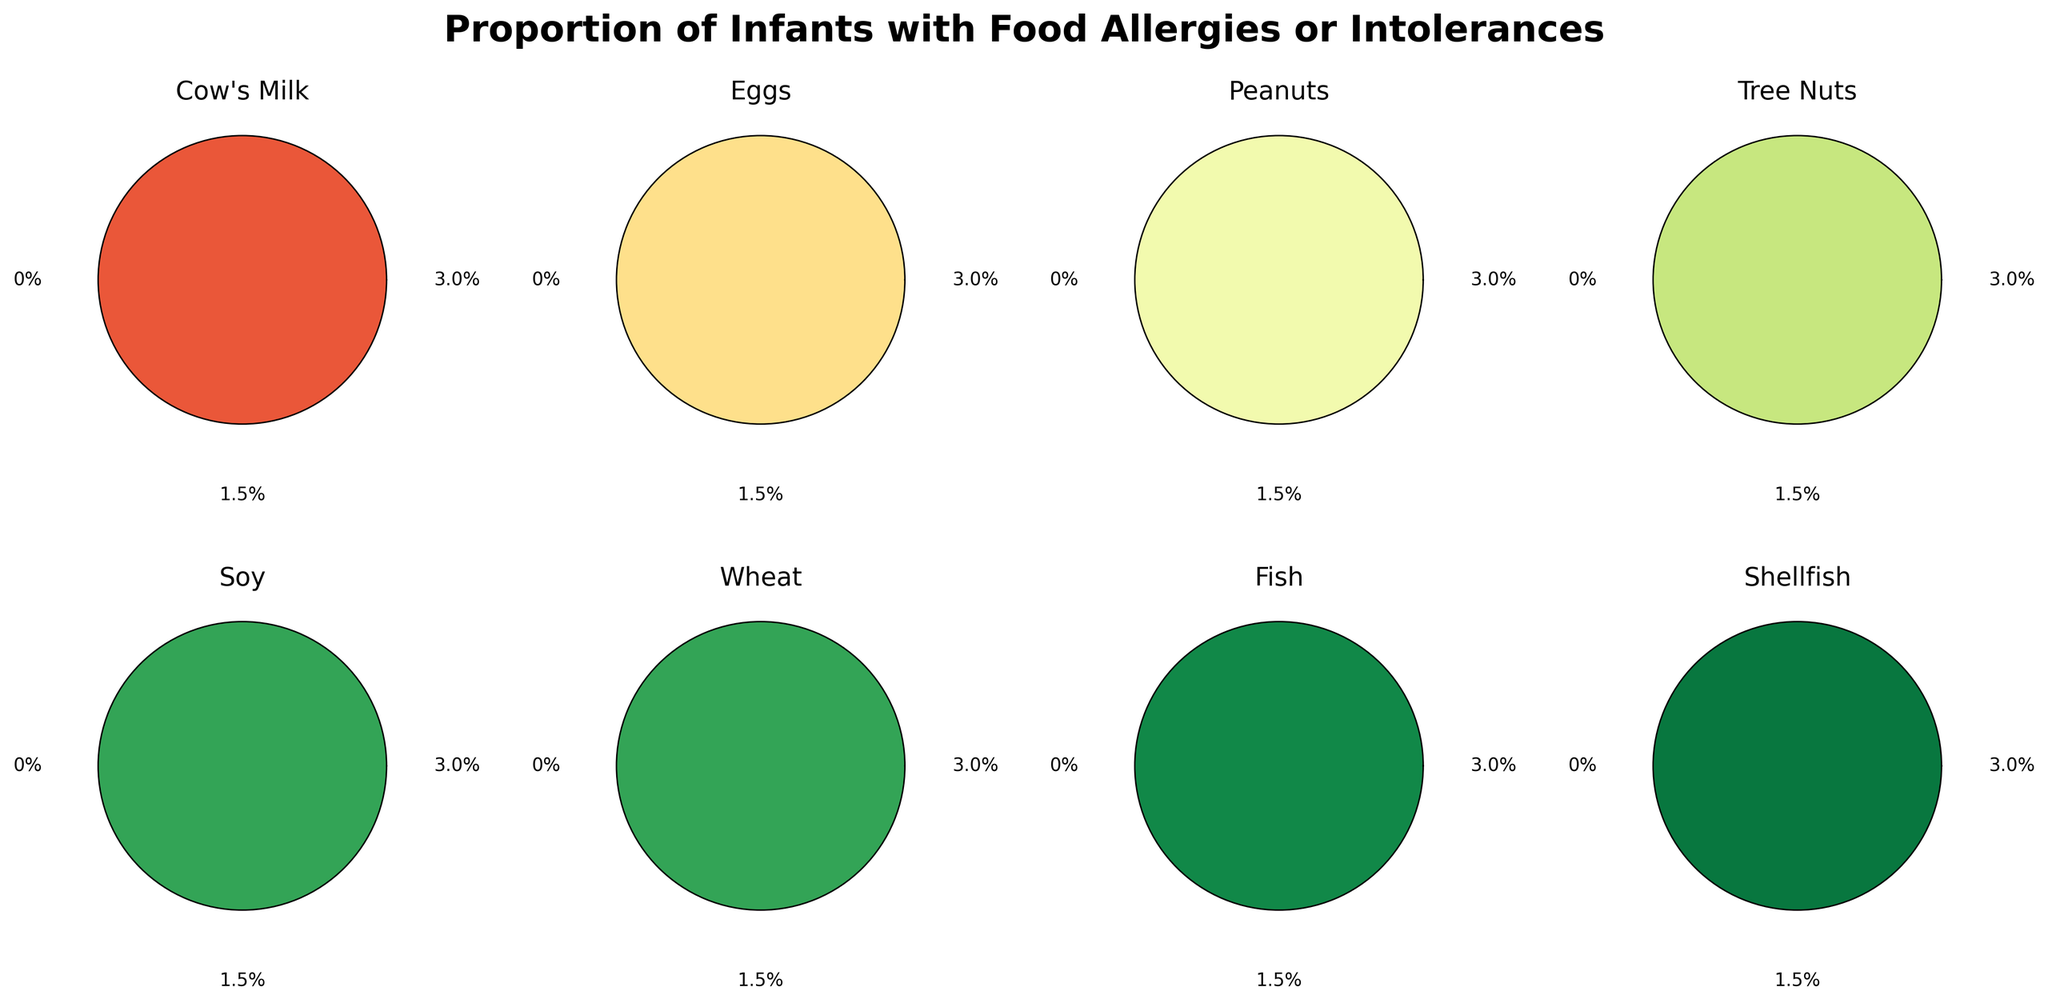What is the title of the figure? The title is located at the top of the figure and is usually in a larger font and often bolded.
Answer: Proportion of Infants with Food Allergies or Intolerances How many allergen categories are shown in the figure? Count the distinct labels or sections presented in the figure for different allergens. There are eight polar charts, each labeled with a different allergen.
Answer: Eight Which allergen category has the highest percentage of infants with allergies or intolerances? Identify the polar chart with the highest percentage labeled. The chart for Cow's Milk shows the highest percentage, labeled as 2.5%.
Answer: Cow's Milk Is the percentage of infants with wheat allergies higher or lower than those with fish allergies? Compare the percentage labels on the polar charts for Wheat and Fish. Wheat shows 0.4% and Fish shows 0.2%.
Answer: Higher What is the total percentage of infants who have allergies to Tree Nuts and Peanuts combined? Add the percentages for Tree Nuts and Peanuts: 1.1% + 1.4% = 2.5%.
Answer: 2.5% Rank the allergens from highest to lowest percentage of infants with allergies or intolerances. List the allergens in descending order based on their percentage labels: Cow's Milk (2.5%), Eggs (1.8%), Peanuts (1.4%), Tree Nuts (1.1%), Soy (0.4%), Wheat (0.4%), Fish (0.2%), Shellfish (0.1%).
Answer: Cow's Milk, Eggs, Peanuts, Tree Nuts, Soy, Wheat, Fish, Shellfish What colors are used in the polar charts? Each of the polar charts uses a different color from a particular colormap, in this case, Set3. The colormap includes various distinct colors.
Answer: Various distinct colors from Set3 colormap What is the median percentage value for all allergens shown? First, list out the percentages: 2.5%, 1.8%, 1.4%, 1.1%, 0.4%, 0.4%, 0.2%, 0.1%. Then order them: 0.1%, 0.2%, 0.4%, 0.4%, 1.1%, 1.4%, 1.8%, 2.5%. The median is the average of the 4th and 5th values: (0.4% + 1.1%)/2 = 0.75%.
Answer: 0.75% Are there any allergens with equal percentages of infants having allergies or intolerances? Check for identical percentage values among the polar charts. Both Soy and Wheat have a percentage value of 0.4%.
Answer: Yes, Soy and Wheat What is the maximum percentage shown on the polar charts? Identify the highest percentage labeled on any of the polar charts. The chart for Cow's Milk shows the highest percentage, labeled as 2.5%.
Answer: 2.5% 